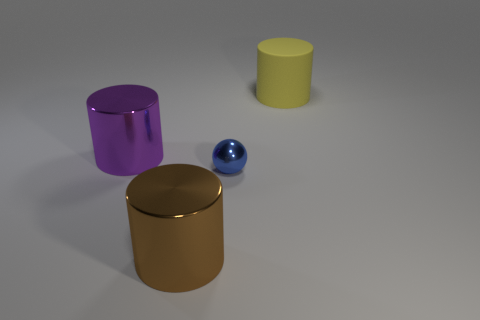Subtract all large shiny cylinders. How many cylinders are left? 1 Add 4 purple shiny things. How many objects exist? 8 Subtract all cylinders. How many objects are left? 1 Add 1 large purple cylinders. How many large purple cylinders are left? 2 Add 2 tiny yellow matte cubes. How many tiny yellow matte cubes exist? 2 Subtract 0 cyan spheres. How many objects are left? 4 Subtract all gray cylinders. Subtract all brown cubes. How many cylinders are left? 3 Subtract all large purple shiny cylinders. Subtract all large matte cylinders. How many objects are left? 2 